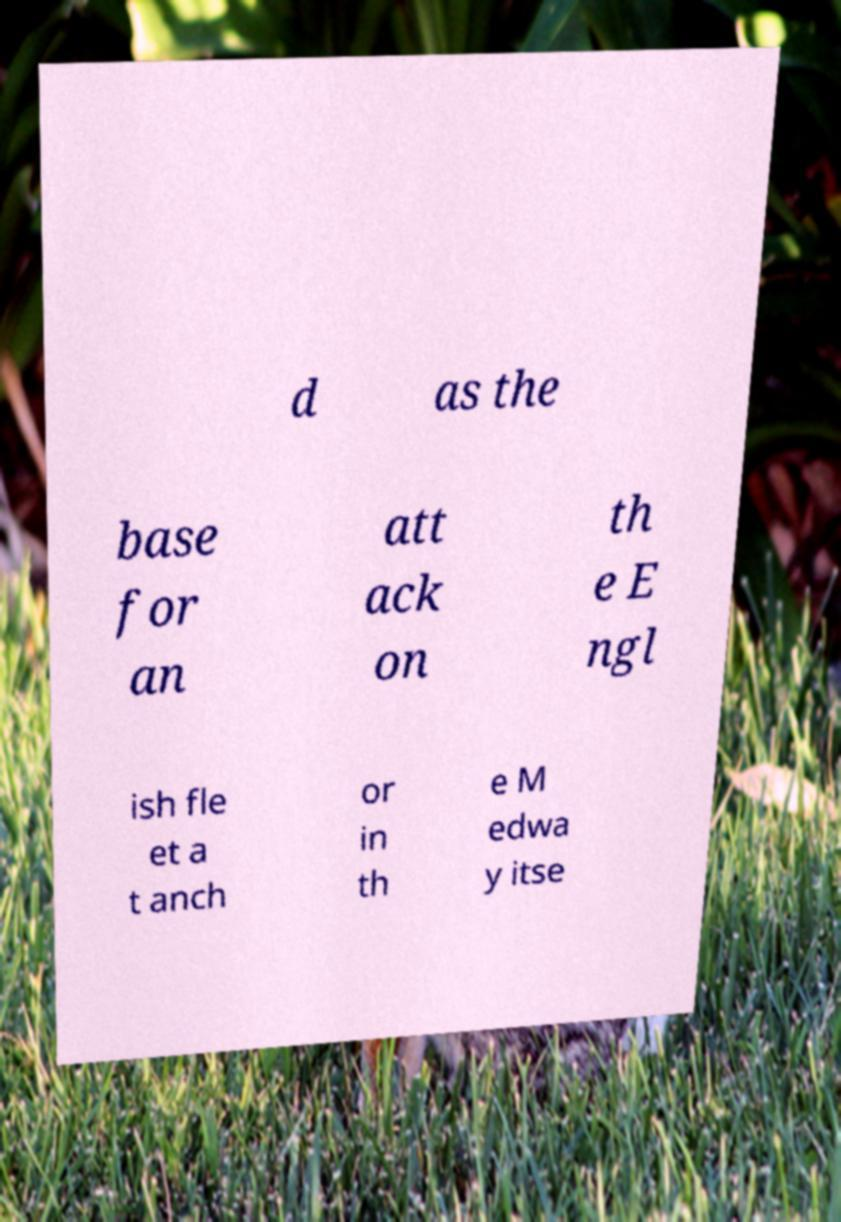Could you assist in decoding the text presented in this image and type it out clearly? d as the base for an att ack on th e E ngl ish fle et a t anch or in th e M edwa y itse 